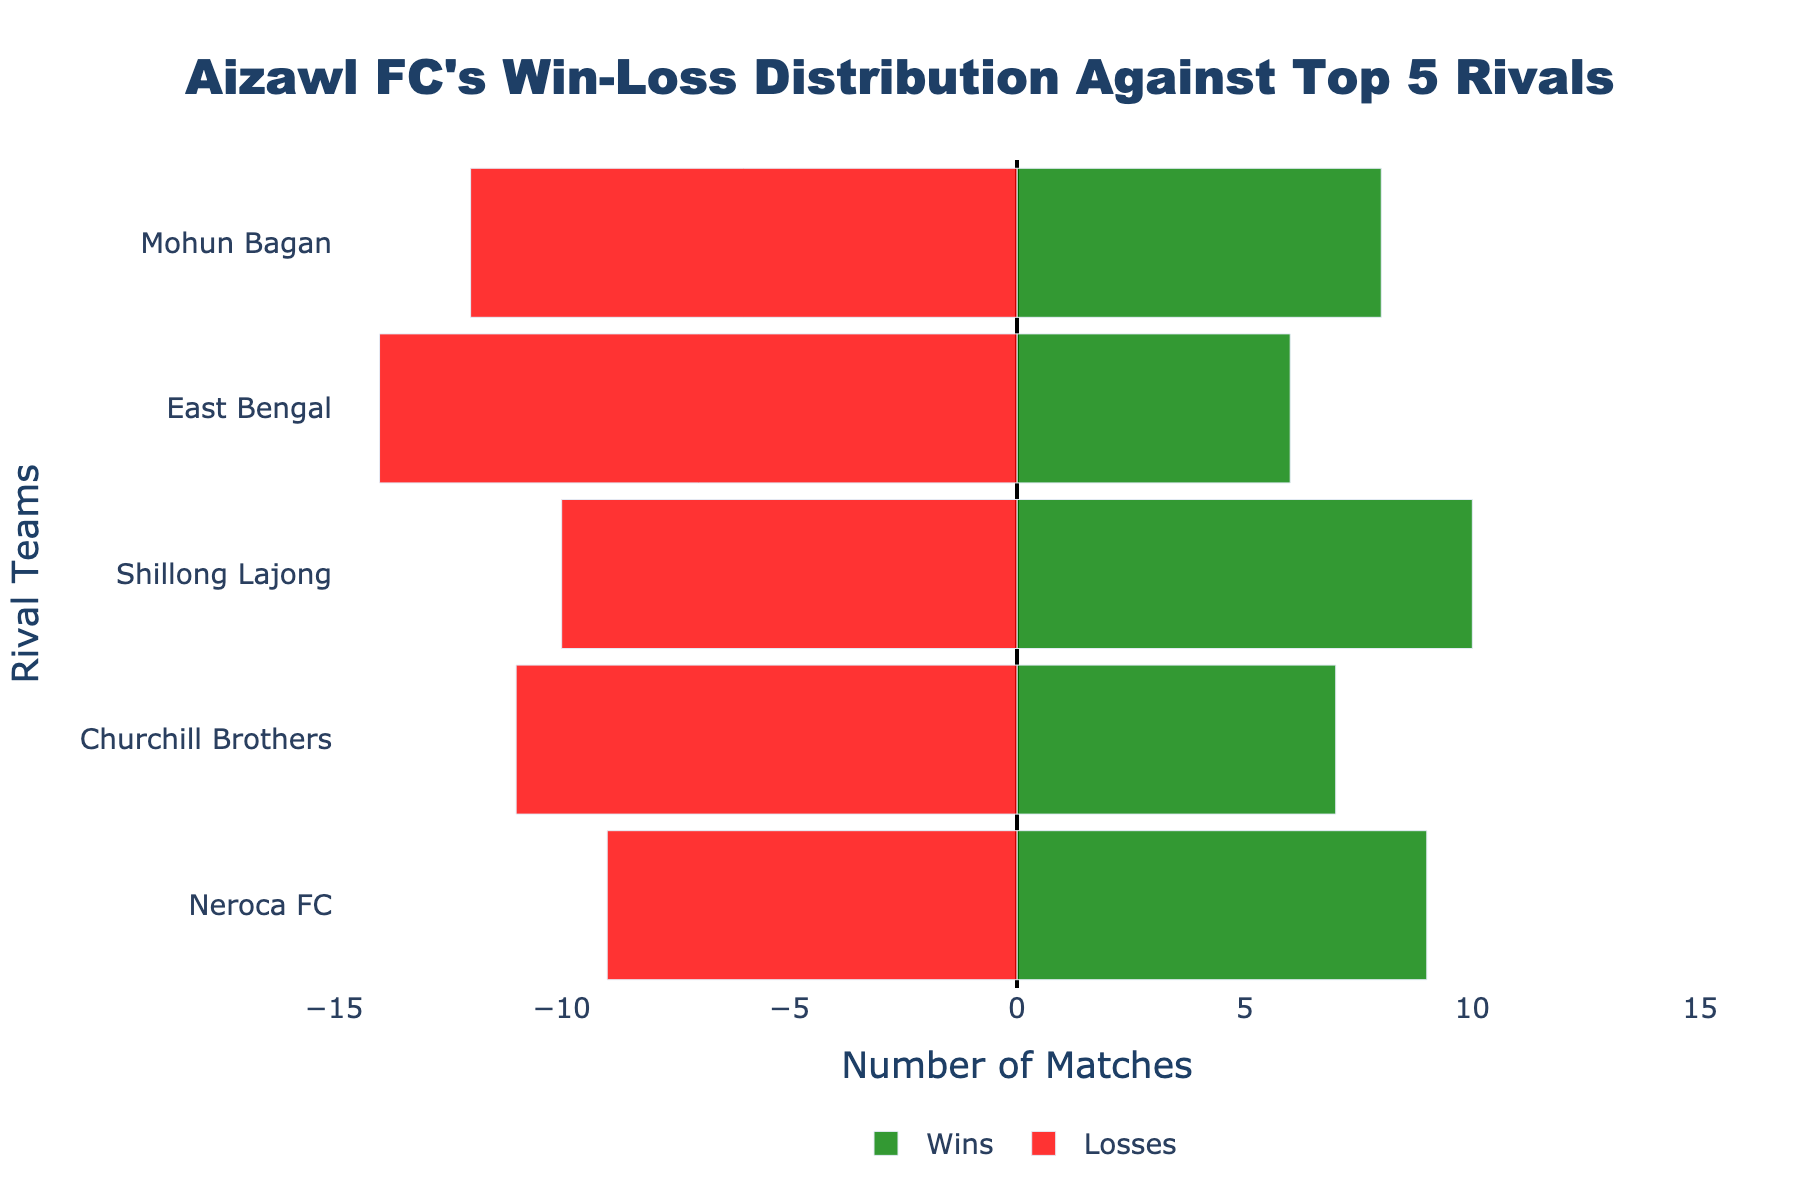Which rival did Aizawl FC win the most matches against? By inspecting the green bars representing the wins for each rival, the longest bar indicates the highest number of wins. For Aizawl FC, the longest green bar is against Shillong Lajong with 10 wins.
Answer: Shillong Lajong Which rival did Aizawl FC lose the most matches against? By examining the red bars representing the losses for each rival, the longest bar reflects the highest number of losses. For Aizawl FC, the longest red bar is against East Bengal with 14 losses.
Answer: East Bengal How many more matches did Aizawl FC lose than win against Mohun Bagan? First, find the number of wins and losses against Mohun Bagan. Wins are 8 and losses are 12. Calculate the difference: 12 - 8 = 4.
Answer: 4 What is the total number of matches played by Aizawl FC against East Bengal? Sum the wins and losses against East Bengal. Wins are 6 and losses are 14. Total matches = 6 + 14 = 20.
Answer: 20 Which rival has the most balanced win-loss distribution by Aizawl FC? The most balanced win-loss distribution will have the smallest difference between wins and losses. Inspect the difference for each rival: Mohun Bagan (4), East Bengal (8), Shillong Lajong (0), Churchill Brothers (4), Neroca FC (0). Shillong Lajong and Neroca FC both have a difference of 0.
Answer: Shillong Lajong and Neroca FC What is the total difference in matches won and lost by Aizawl FC against all top 5 rivals combined? Calculate the difference for each rival and sum them up. Differences are: Mohun Bagan (4), East Bengal (8), Shillong Lajong (0), Churchill Brothers (4), and Neroca FC (0). Total difference = 4 + 8 + 0 + 4 + 0 = 16.
Answer: 16 Which rival has the smallest number of matches lost by Aizawl FC? By inspecting the height of the red bars representing losses for each rival, the smallest bar indicates the fewest losses. For Aizawl FC, Neroca FC and Shillong Lajong both have 9 losses, which is the smallest.
Answer: Neroca FC and Shillong Lajong 